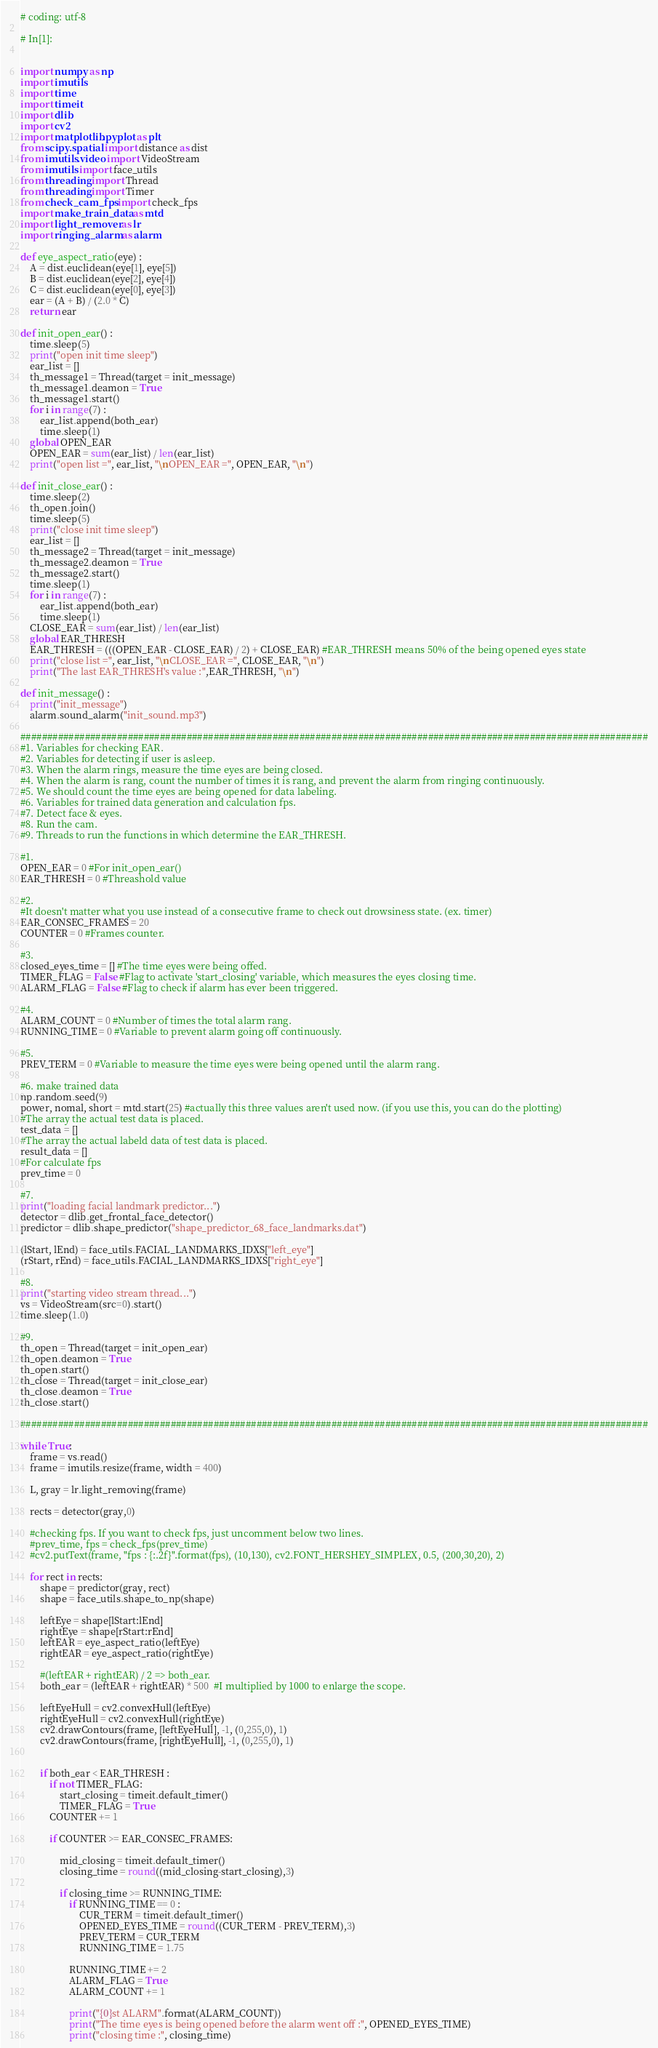Convert code to text. <code><loc_0><loc_0><loc_500><loc_500><_Python_>
# coding: utf-8

# In[1]:


import numpy as np
import imutils
import time
import timeit
import dlib
import cv2
import matplotlib.pyplot as plt
from scipy.spatial import distance as dist
from imutils.video import VideoStream
from imutils import face_utils
from threading import Thread
from threading import Timer
from check_cam_fps import check_fps
import make_train_data as mtd
import light_remover as lr
import ringing_alarm as alarm

def eye_aspect_ratio(eye) :
    A = dist.euclidean(eye[1], eye[5])
    B = dist.euclidean(eye[2], eye[4])
    C = dist.euclidean(eye[0], eye[3])
    ear = (A + B) / (2.0 * C)
    return ear
    
def init_open_ear() :
    time.sleep(5)
    print("open init time sleep")
    ear_list = []
    th_message1 = Thread(target = init_message)
    th_message1.deamon = True
    th_message1.start()
    for i in range(7) :
        ear_list.append(both_ear)
        time.sleep(1)
    global OPEN_EAR
    OPEN_EAR = sum(ear_list) / len(ear_list)
    print("open list =", ear_list, "\nOPEN_EAR =", OPEN_EAR, "\n")

def init_close_ear() : 
    time.sleep(2)
    th_open.join()
    time.sleep(5)
    print("close init time sleep")
    ear_list = []
    th_message2 = Thread(target = init_message)
    th_message2.deamon = True
    th_message2.start()
    time.sleep(1)
    for i in range(7) :
        ear_list.append(both_ear)
        time.sleep(1)
    CLOSE_EAR = sum(ear_list) / len(ear_list)
    global EAR_THRESH
    EAR_THRESH = (((OPEN_EAR - CLOSE_EAR) / 2) + CLOSE_EAR) #EAR_THRESH means 50% of the being opened eyes state
    print("close list =", ear_list, "\nCLOSE_EAR =", CLOSE_EAR, "\n")
    print("The last EAR_THRESH's value :",EAR_THRESH, "\n")

def init_message() :
    print("init_message")
    alarm.sound_alarm("init_sound.mp3")

#####################################################################################################################
#1. Variables for checking EAR.
#2. Variables for detecting if user is asleep.
#3. When the alarm rings, measure the time eyes are being closed.
#4. When the alarm is rang, count the number of times it is rang, and prevent the alarm from ringing continuously.
#5. We should count the time eyes are being opened for data labeling.
#6. Variables for trained data generation and calculation fps.
#7. Detect face & eyes.
#8. Run the cam.
#9. Threads to run the functions in which determine the EAR_THRESH. 

#1.
OPEN_EAR = 0 #For init_open_ear()
EAR_THRESH = 0 #Threashold value

#2.
#It doesn't matter what you use instead of a consecutive frame to check out drowsiness state. (ex. timer)
EAR_CONSEC_FRAMES = 20 
COUNTER = 0 #Frames counter.

#3.
closed_eyes_time = [] #The time eyes were being offed.
TIMER_FLAG = False #Flag to activate 'start_closing' variable, which measures the eyes closing time.
ALARM_FLAG = False #Flag to check if alarm has ever been triggered.

#4. 
ALARM_COUNT = 0 #Number of times the total alarm rang.
RUNNING_TIME = 0 #Variable to prevent alarm going off continuously.

#5.    
PREV_TERM = 0 #Variable to measure the time eyes were being opened until the alarm rang.

#6. make trained data 
np.random.seed(9)
power, nomal, short = mtd.start(25) #actually this three values aren't used now. (if you use this, you can do the plotting)
#The array the actual test data is placed.
test_data = []
#The array the actual labeld data of test data is placed.
result_data = []
#For calculate fps
prev_time = 0

#7. 
print("loading facial landmark predictor...")
detector = dlib.get_frontal_face_detector()
predictor = dlib.shape_predictor("shape_predictor_68_face_landmarks.dat")

(lStart, lEnd) = face_utils.FACIAL_LANDMARKS_IDXS["left_eye"]
(rStart, rEnd) = face_utils.FACIAL_LANDMARKS_IDXS["right_eye"]

#8.
print("starting video stream thread...")
vs = VideoStream(src=0).start()
time.sleep(1.0)

#9.
th_open = Thread(target = init_open_ear)
th_open.deamon = True
th_open.start()
th_close = Thread(target = init_close_ear)
th_close.deamon = True
th_close.start()

#####################################################################################################################

while True:
    frame = vs.read()
    frame = imutils.resize(frame, width = 400)
    
    L, gray = lr.light_removing(frame)
    
    rects = detector(gray,0)
    
    #checking fps. If you want to check fps, just uncomment below two lines.
    #prev_time, fps = check_fps(prev_time)
    #cv2.putText(frame, "fps : {:.2f}".format(fps), (10,130), cv2.FONT_HERSHEY_SIMPLEX, 0.5, (200,30,20), 2)

    for rect in rects:
        shape = predictor(gray, rect)
        shape = face_utils.shape_to_np(shape)

        leftEye = shape[lStart:lEnd]
        rightEye = shape[rStart:rEnd]
        leftEAR = eye_aspect_ratio(leftEye)
        rightEAR = eye_aspect_ratio(rightEye)

        #(leftEAR + rightEAR) / 2 => both_ear. 
        both_ear = (leftEAR + rightEAR) * 500  #I multiplied by 1000 to enlarge the scope.

        leftEyeHull = cv2.convexHull(leftEye)
        rightEyeHull = cv2.convexHull(rightEye)
        cv2.drawContours(frame, [leftEyeHull], -1, (0,255,0), 1)
        cv2.drawContours(frame, [rightEyeHull], -1, (0,255,0), 1)
        

        if both_ear < EAR_THRESH :
            if not TIMER_FLAG:
                start_closing = timeit.default_timer()
                TIMER_FLAG = True
            COUNTER += 1

            if COUNTER >= EAR_CONSEC_FRAMES:

                mid_closing = timeit.default_timer()
                closing_time = round((mid_closing-start_closing),3)

                if closing_time >= RUNNING_TIME:
                    if RUNNING_TIME == 0 :
                        CUR_TERM = timeit.default_timer()
                        OPENED_EYES_TIME = round((CUR_TERM - PREV_TERM),3)
                        PREV_TERM = CUR_TERM
                        RUNNING_TIME = 1.75

                    RUNNING_TIME += 2
                    ALARM_FLAG = True
                    ALARM_COUNT += 1

                    print("{0}st ALARM".format(ALARM_COUNT))
                    print("The time eyes is being opened before the alarm went off :", OPENED_EYES_TIME)
                    print("closing time :", closing_time)</code> 